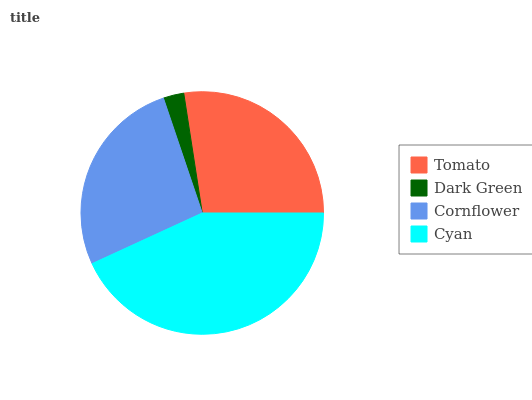Is Dark Green the minimum?
Answer yes or no. Yes. Is Cyan the maximum?
Answer yes or no. Yes. Is Cornflower the minimum?
Answer yes or no. No. Is Cornflower the maximum?
Answer yes or no. No. Is Cornflower greater than Dark Green?
Answer yes or no. Yes. Is Dark Green less than Cornflower?
Answer yes or no. Yes. Is Dark Green greater than Cornflower?
Answer yes or no. No. Is Cornflower less than Dark Green?
Answer yes or no. No. Is Tomato the high median?
Answer yes or no. Yes. Is Cornflower the low median?
Answer yes or no. Yes. Is Dark Green the high median?
Answer yes or no. No. Is Tomato the low median?
Answer yes or no. No. 